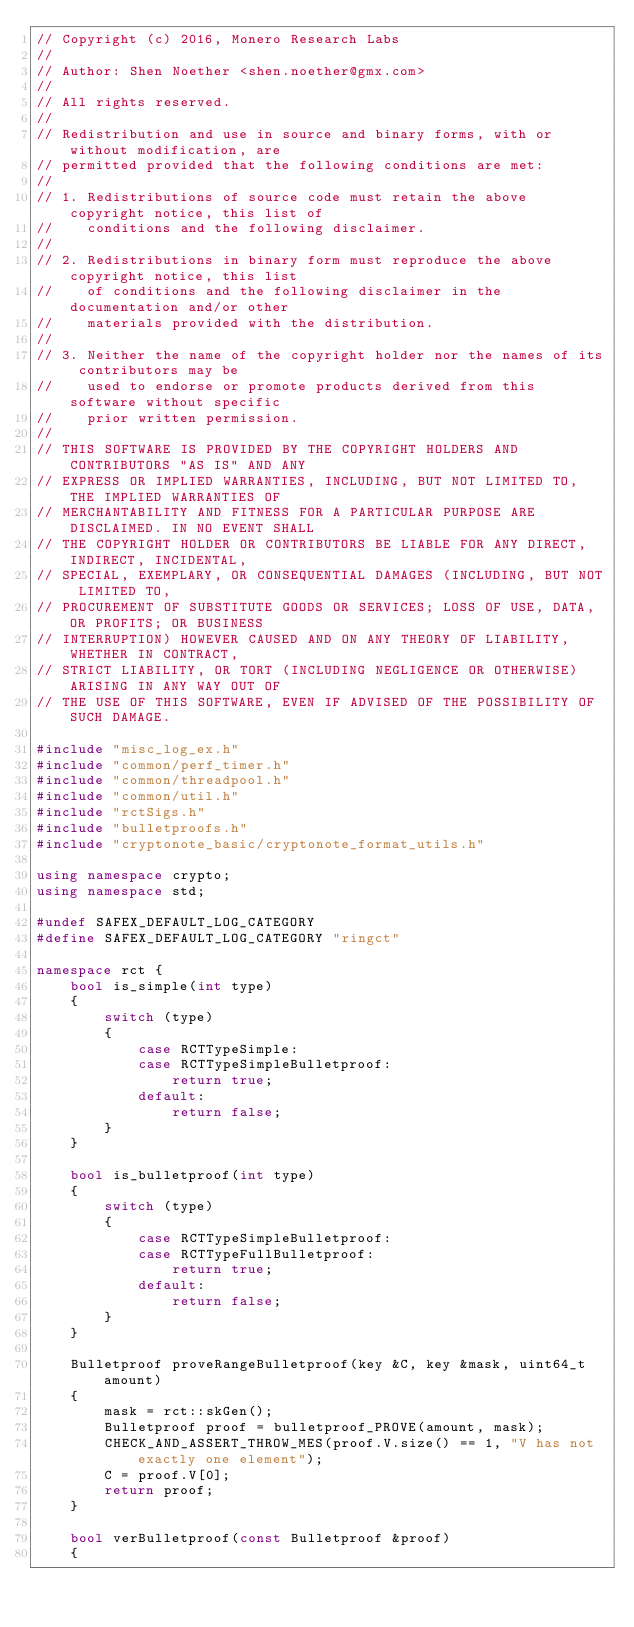<code> <loc_0><loc_0><loc_500><loc_500><_C++_>// Copyright (c) 2016, Monero Research Labs
//
// Author: Shen Noether <shen.noether@gmx.com>
// 
// All rights reserved.
// 
// Redistribution and use in source and binary forms, with or without modification, are
// permitted provided that the following conditions are met:
// 
// 1. Redistributions of source code must retain the above copyright notice, this list of
//    conditions and the following disclaimer.
// 
// 2. Redistributions in binary form must reproduce the above copyright notice, this list
//    of conditions and the following disclaimer in the documentation and/or other
//    materials provided with the distribution.
// 
// 3. Neither the name of the copyright holder nor the names of its contributors may be
//    used to endorse or promote products derived from this software without specific
//    prior written permission.
// 
// THIS SOFTWARE IS PROVIDED BY THE COPYRIGHT HOLDERS AND CONTRIBUTORS "AS IS" AND ANY
// EXPRESS OR IMPLIED WARRANTIES, INCLUDING, BUT NOT LIMITED TO, THE IMPLIED WARRANTIES OF
// MERCHANTABILITY AND FITNESS FOR A PARTICULAR PURPOSE ARE DISCLAIMED. IN NO EVENT SHALL
// THE COPYRIGHT HOLDER OR CONTRIBUTORS BE LIABLE FOR ANY DIRECT, INDIRECT, INCIDENTAL,
// SPECIAL, EXEMPLARY, OR CONSEQUENTIAL DAMAGES (INCLUDING, BUT NOT LIMITED TO,
// PROCUREMENT OF SUBSTITUTE GOODS OR SERVICES; LOSS OF USE, DATA, OR PROFITS; OR BUSINESS
// INTERRUPTION) HOWEVER CAUSED AND ON ANY THEORY OF LIABILITY, WHETHER IN CONTRACT,
// STRICT LIABILITY, OR TORT (INCLUDING NEGLIGENCE OR OTHERWISE) ARISING IN ANY WAY OUT OF
// THE USE OF THIS SOFTWARE, EVEN IF ADVISED OF THE POSSIBILITY OF SUCH DAMAGE.

#include "misc_log_ex.h"
#include "common/perf_timer.h"
#include "common/threadpool.h"
#include "common/util.h"
#include "rctSigs.h"
#include "bulletproofs.h"
#include "cryptonote_basic/cryptonote_format_utils.h"

using namespace crypto;
using namespace std;

#undef SAFEX_DEFAULT_LOG_CATEGORY
#define SAFEX_DEFAULT_LOG_CATEGORY "ringct"

namespace rct {
    bool is_simple(int type)
    {
        switch (type)
        {
            case RCTTypeSimple:
            case RCTTypeSimpleBulletproof:
                return true;
            default:
                return false;
        }
    }

    bool is_bulletproof(int type)
    {
        switch (type)
        {
            case RCTTypeSimpleBulletproof:
            case RCTTypeFullBulletproof:
                return true;
            default:
                return false;
        }
    }

    Bulletproof proveRangeBulletproof(key &C, key &mask, uint64_t amount)
    {
        mask = rct::skGen();
        Bulletproof proof = bulletproof_PROVE(amount, mask);
        CHECK_AND_ASSERT_THROW_MES(proof.V.size() == 1, "V has not exactly one element");
        C = proof.V[0];
        return proof;
    }

    bool verBulletproof(const Bulletproof &proof)
    {</code> 